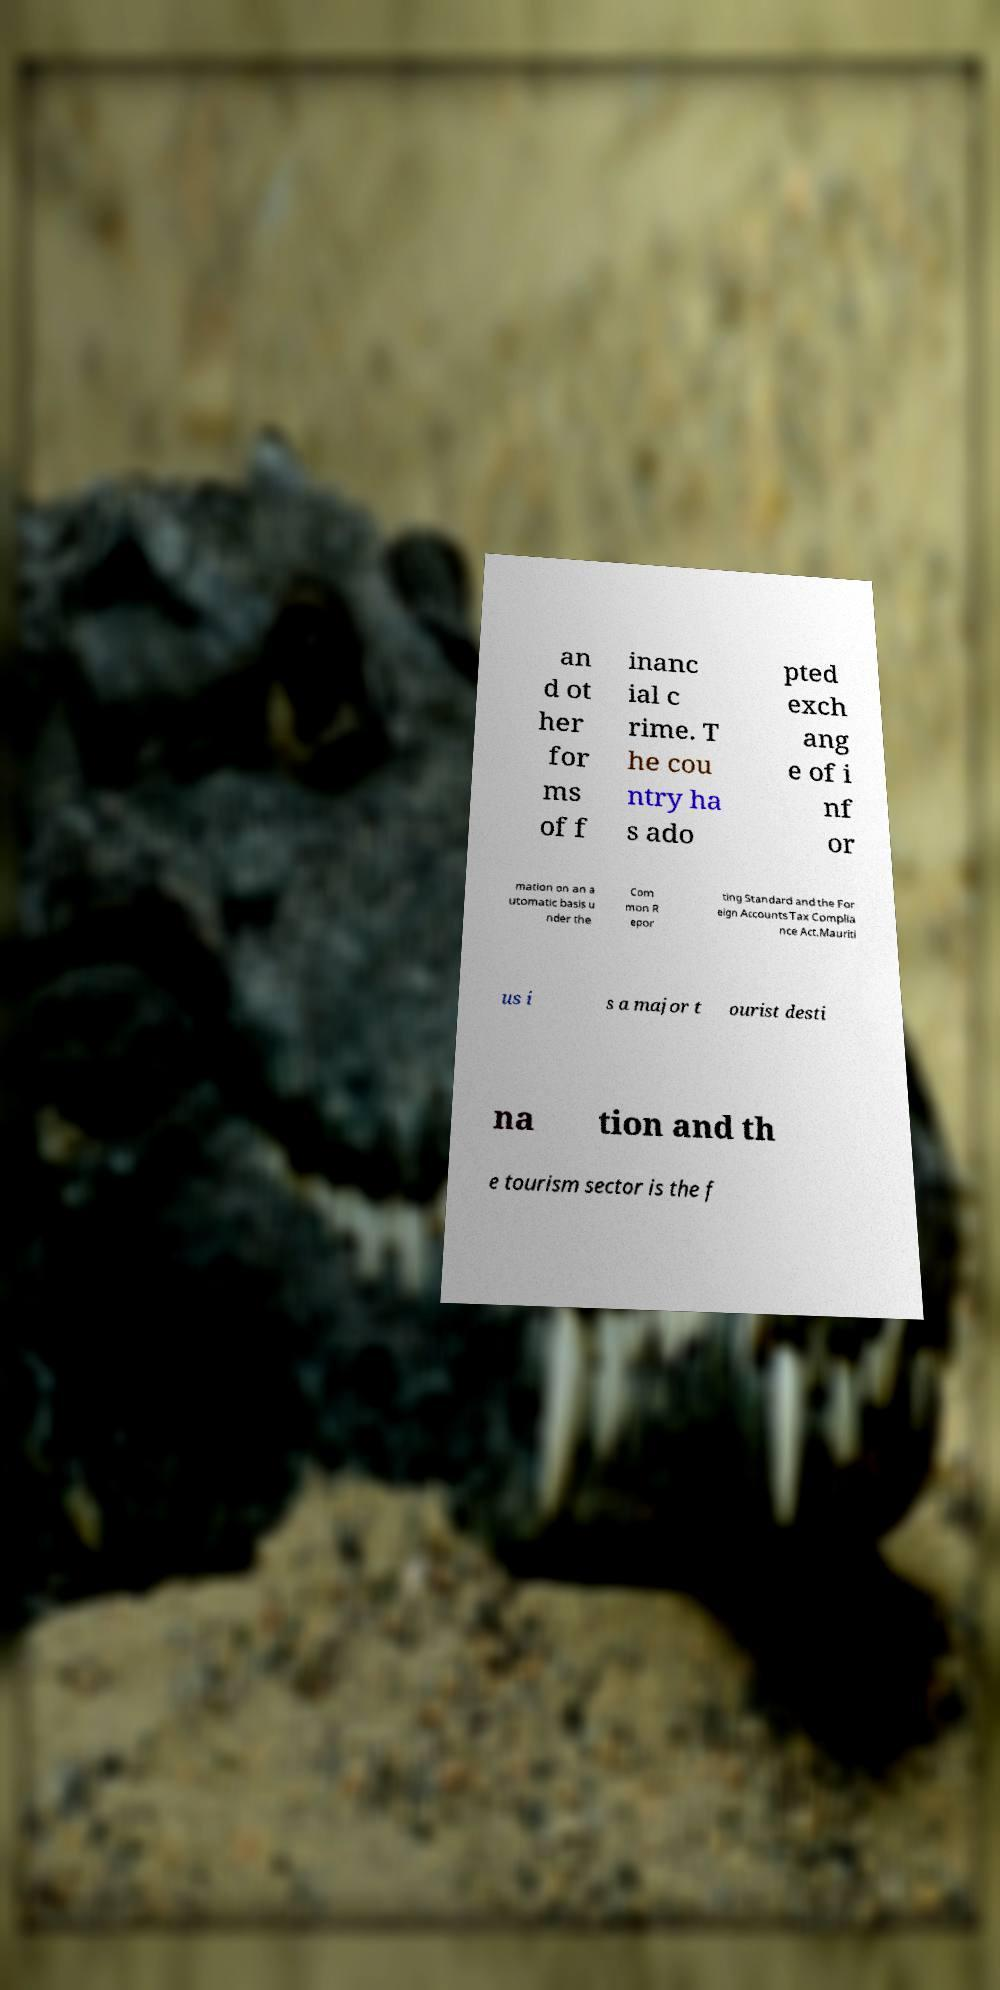What messages or text are displayed in this image? I need them in a readable, typed format. an d ot her for ms of f inanc ial c rime. T he cou ntry ha s ado pted exch ang e of i nf or mation on an a utomatic basis u nder the Com mon R epor ting Standard and the For eign Accounts Tax Complia nce Act.Mauriti us i s a major t ourist desti na tion and th e tourism sector is the f 